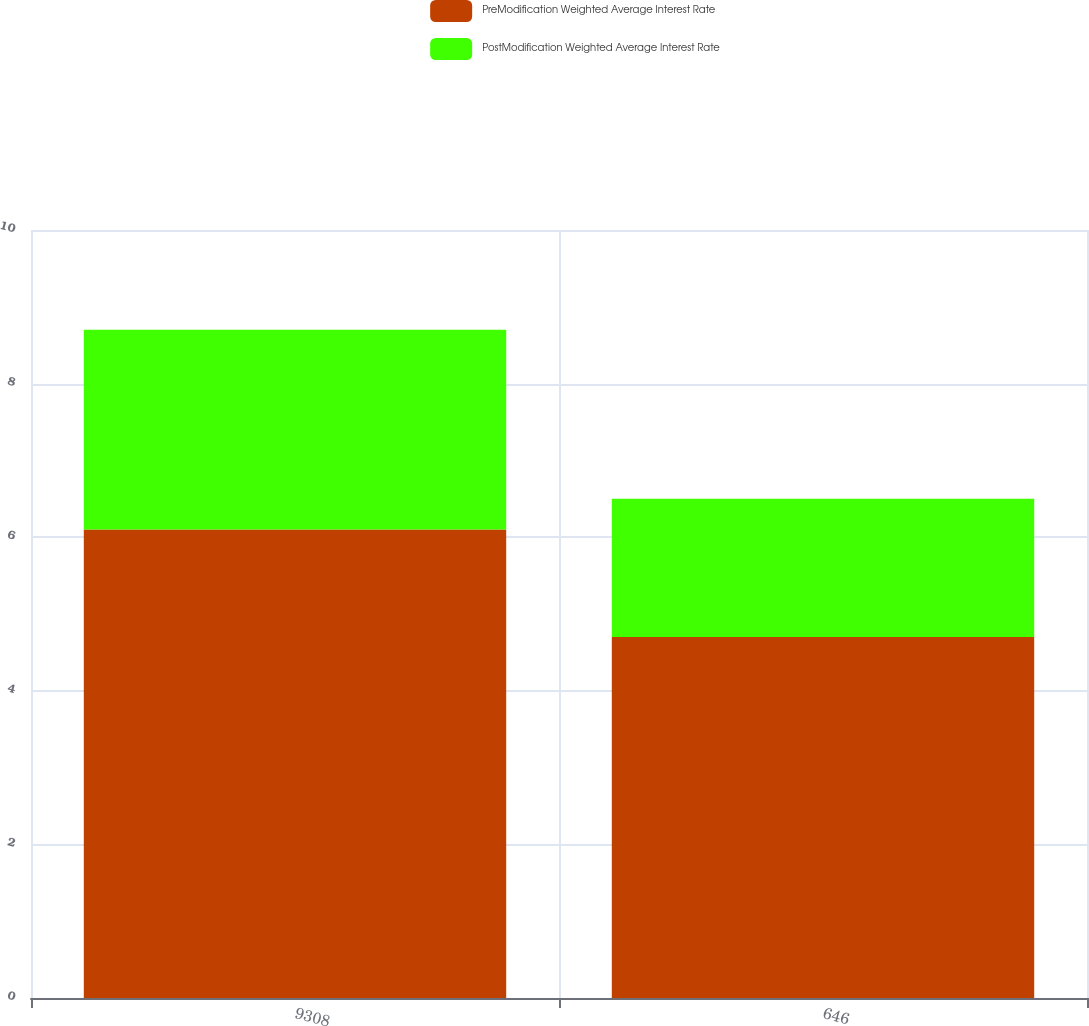Convert chart. <chart><loc_0><loc_0><loc_500><loc_500><stacked_bar_chart><ecel><fcel>9308<fcel>646<nl><fcel>PreModification Weighted Average Interest Rate<fcel>6.1<fcel>4.7<nl><fcel>PostModification Weighted Average Interest Rate<fcel>2.6<fcel>1.8<nl></chart> 